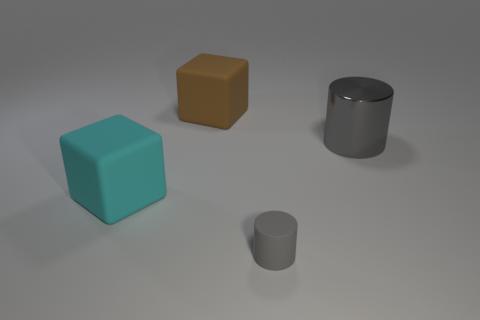Add 4 cyan matte objects. How many objects exist? 8 Subtract 0 green cubes. How many objects are left? 4 Subtract all cyan things. Subtract all cyan rubber things. How many objects are left? 2 Add 3 big gray metallic cylinders. How many big gray metallic cylinders are left? 4 Add 4 large rubber objects. How many large rubber objects exist? 6 